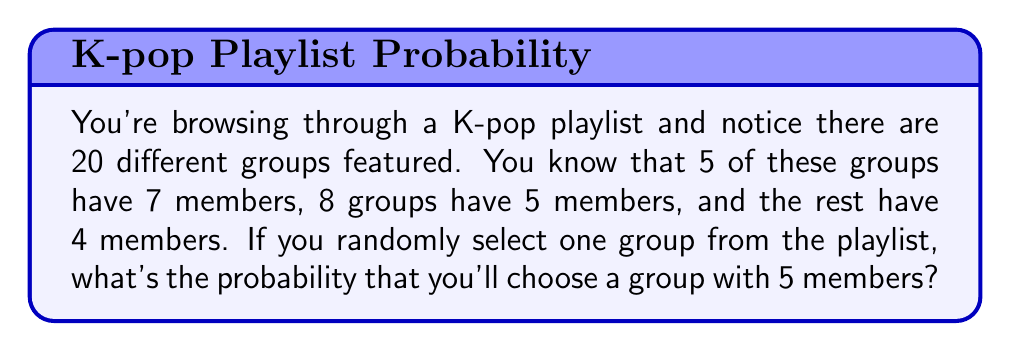Provide a solution to this math problem. To solve this problem, we need to use the basic concept of probability:

$$ P(\text{event}) = \frac{\text{number of favorable outcomes}}{\text{total number of possible outcomes}} $$

Let's break down the given information:
1. Total number of groups: 20
2. Number of groups with 7 members: 5
3. Number of groups with 5 members: 8
4. Number of groups with 4 members: 20 - 5 - 8 = 7

We want to find the probability of selecting a group with 5 members.

Favorable outcomes: 8 groups have 5 members
Total possible outcomes: 20 groups in total

Therefore, the probability is:

$$ P(\text{selecting a group with 5 members}) = \frac{8}{20} $$

We can simplify this fraction:

$$ \frac{8}{20} = \frac{2}{5} = 0.4 $$

This can also be expressed as a percentage:

$$ 0.4 \times 100\% = 40\% $$
Answer: The probability of randomly selecting a group with 5 members is $\frac{2}{5}$ or 0.4 or 40%. 